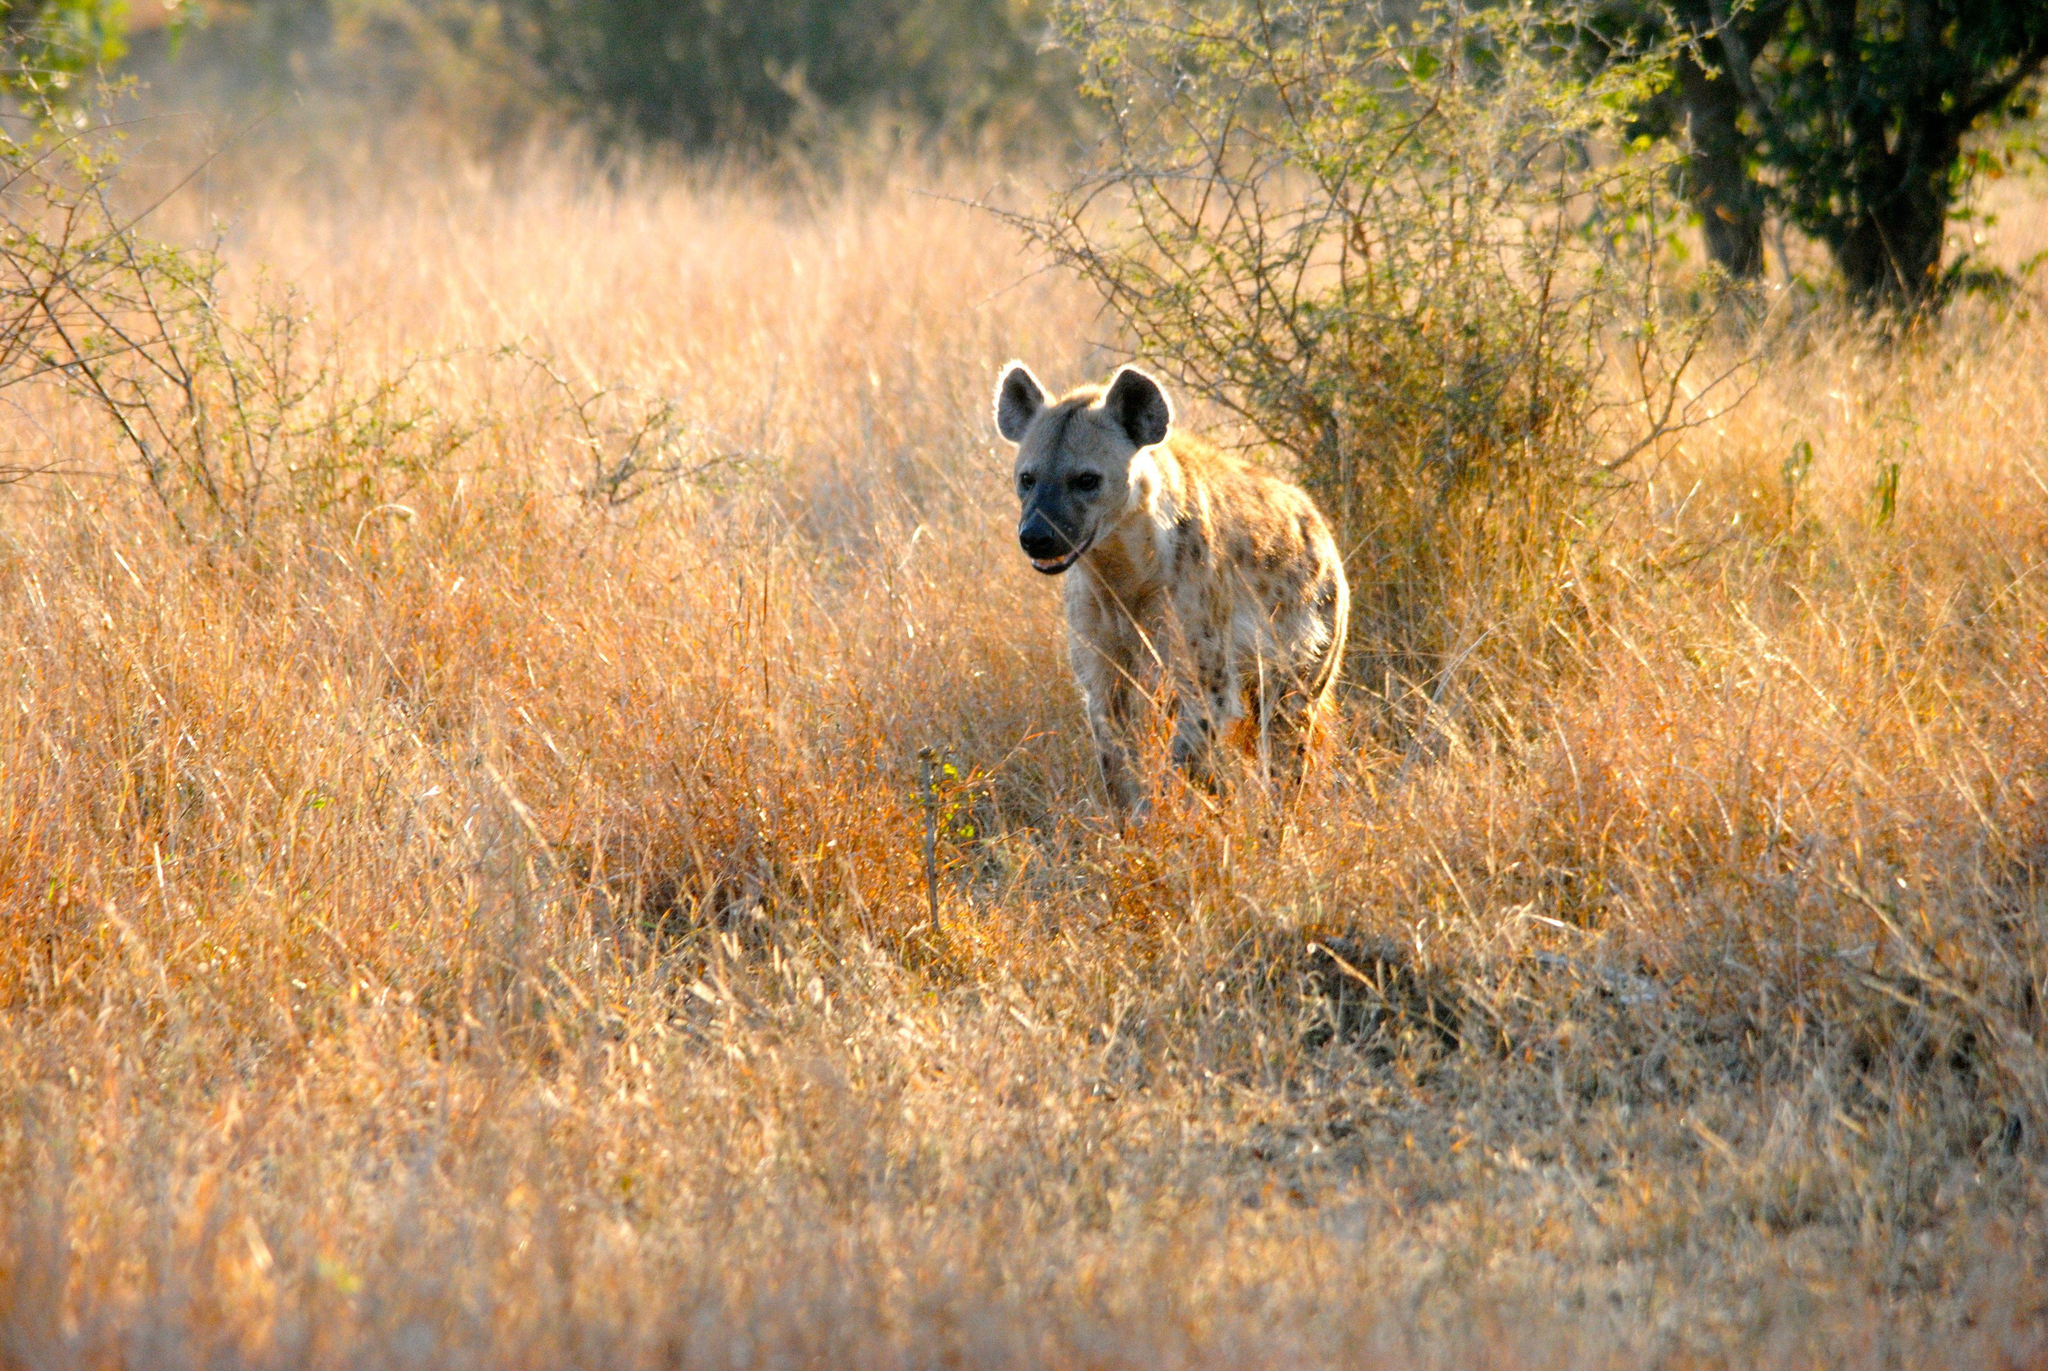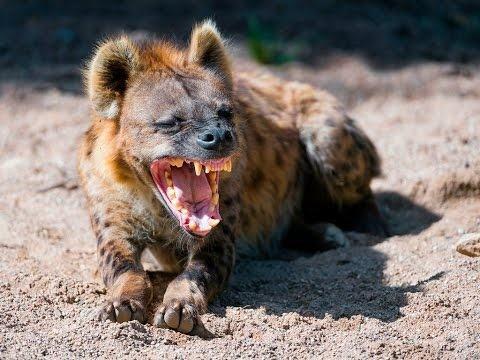The first image is the image on the left, the second image is the image on the right. Evaluate the accuracy of this statement regarding the images: "There are two hyenas.". Is it true? Answer yes or no. Yes. The first image is the image on the left, the second image is the image on the right. Given the left and right images, does the statement "One image shows a single hyena moving forward and slightly to the left, and the other image includes a hyena with a wide-open fang-baring mouth and its body facing forward." hold true? Answer yes or no. Yes. 